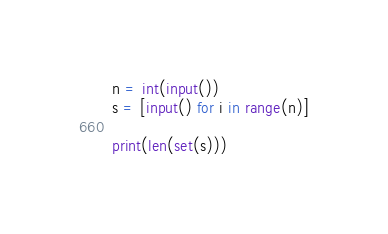Convert code to text. <code><loc_0><loc_0><loc_500><loc_500><_Python_>n = int(input())
s = [input() for i in range(n)]

print(len(set(s)))</code> 